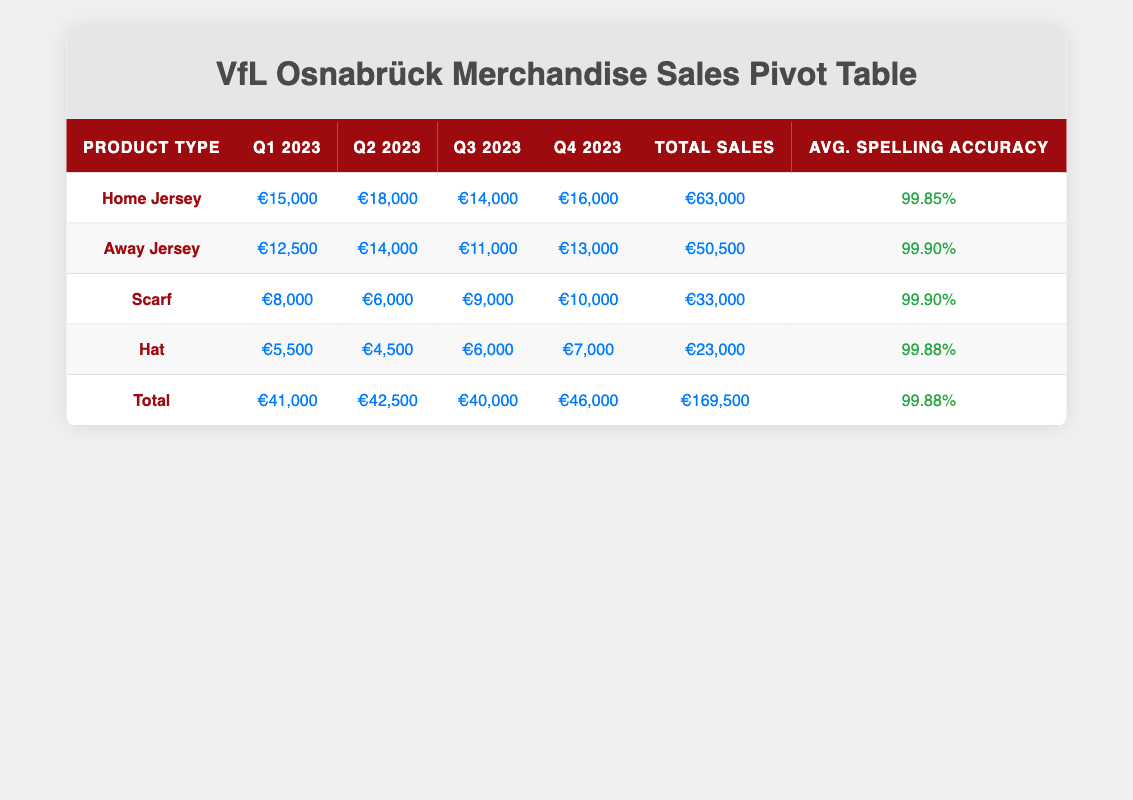What was the total sales amount for the Home Jersey? For the Home Jersey, the sales amounts for each quarter are €15,000 (Q1), €18,000 (Q2), €14,000 (Q3), and €16,000 (Q4). Adding these up gives €15,000 + €18,000 + €14,000 + €16,000 = €63,000.
Answer: €63,000 What is the average spelling accuracy for the Away Jersey? The spelling accuracy for the Away Jersey in each quarter is 99.9% (Q1), 100% (Q2), 99.8% (Q3), and 99.9% (Q4). To find the average, we sum these percentages to get 99.9 + 100 + 99.8 + 99.9 = 399.6 and then divide by 4 (the number of quarters) to get 399.6/4 = 99.9%.
Answer: 99.9% Did the sales amount for the Scarf increase from Q1 to Q2? The sales amount for the Scarf in Q1 is €8,000, and in Q2 it is €6,000. Since €6,000 is less than €8,000, the sales amount decreased.
Answer: No Which product type had the highest total sales? The total sales were €63,000 for Home Jerseys, €50,500 for Away Jerseys, €33,000 for Scarves, and €23,000 for Hats. The Home Jersey has the highest sales amount at €63,000.
Answer: Home Jersey What was the total sales amount across all product types in Q4? For Q4, the sales amounts are €16,000 (Home Jersey), €13,000 (Away Jersey), €10,000 (Scarf), and €7,000 (Hat). Adding these gives: €16,000 + €13,000 + €10,000 + €7,000 = €46,000.
Answer: €46,000 Is the average spelling accuracy for all products above 99.8%? The average spelling accuracy for all product types is calculated as follows: Home Jersey (99.85) + Away Jersey (99.90) + Scarf (99.90) + Hat (99.88) = 399.53. Dividing by 4 gives an average of 99.88%, which is above 99.8%.
Answer: Yes 